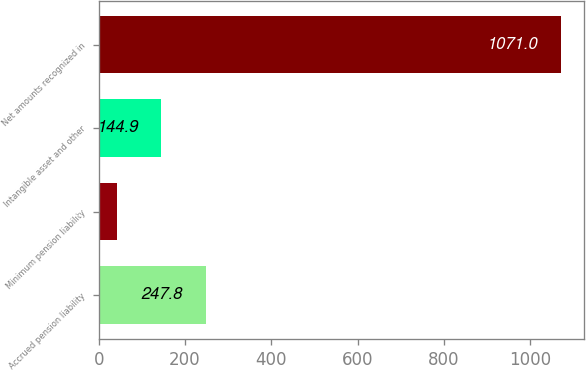<chart> <loc_0><loc_0><loc_500><loc_500><bar_chart><fcel>Accrued pension liability<fcel>Minimum pension liability<fcel>Intangible asset and other<fcel>Net amounts recognized in<nl><fcel>247.8<fcel>42<fcel>144.9<fcel>1071<nl></chart> 